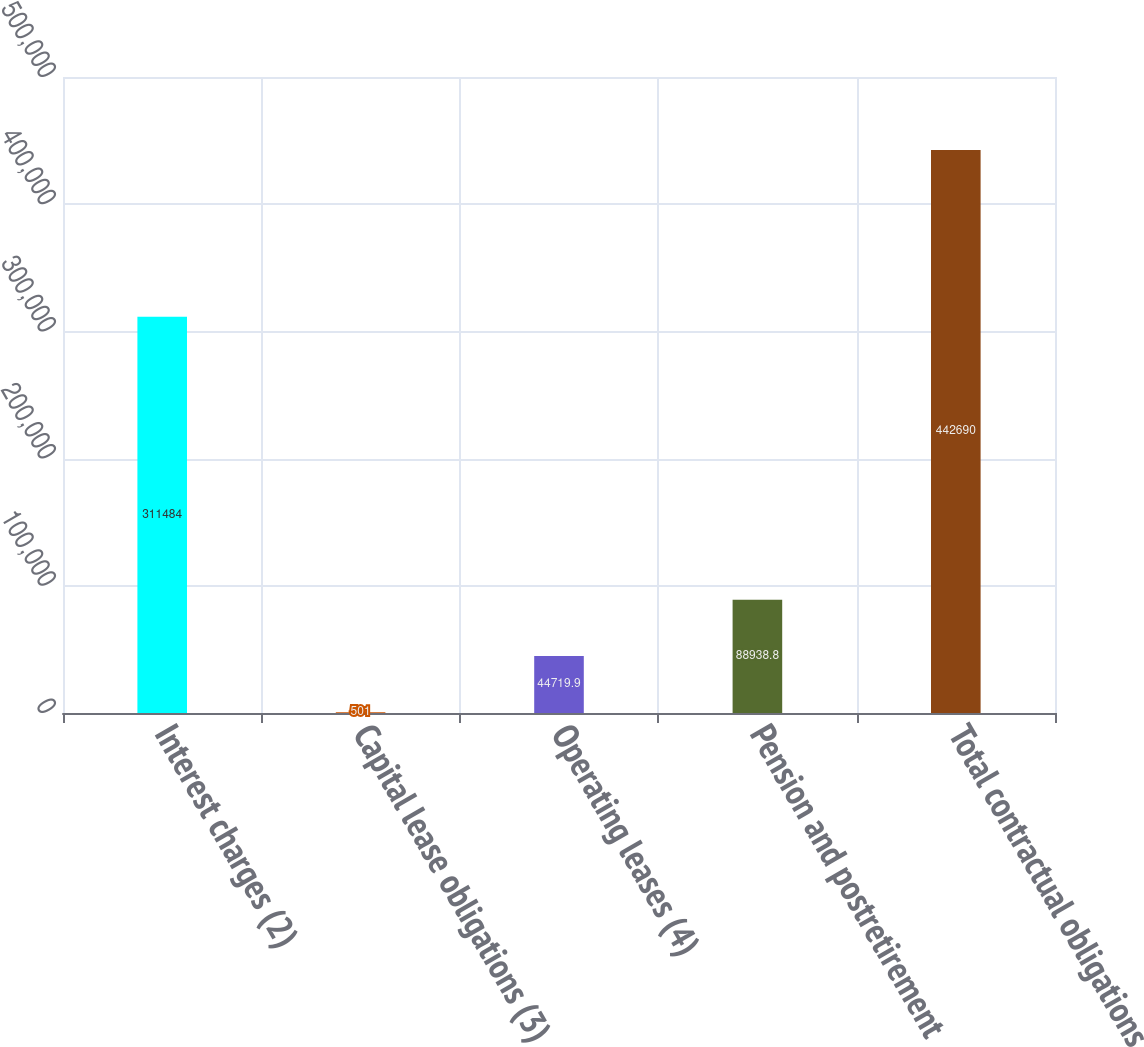<chart> <loc_0><loc_0><loc_500><loc_500><bar_chart><fcel>Interest charges (2)<fcel>Capital lease obligations (3)<fcel>Operating leases (4)<fcel>Pension and postretirement<fcel>Total contractual obligations<nl><fcel>311484<fcel>501<fcel>44719.9<fcel>88938.8<fcel>442690<nl></chart> 